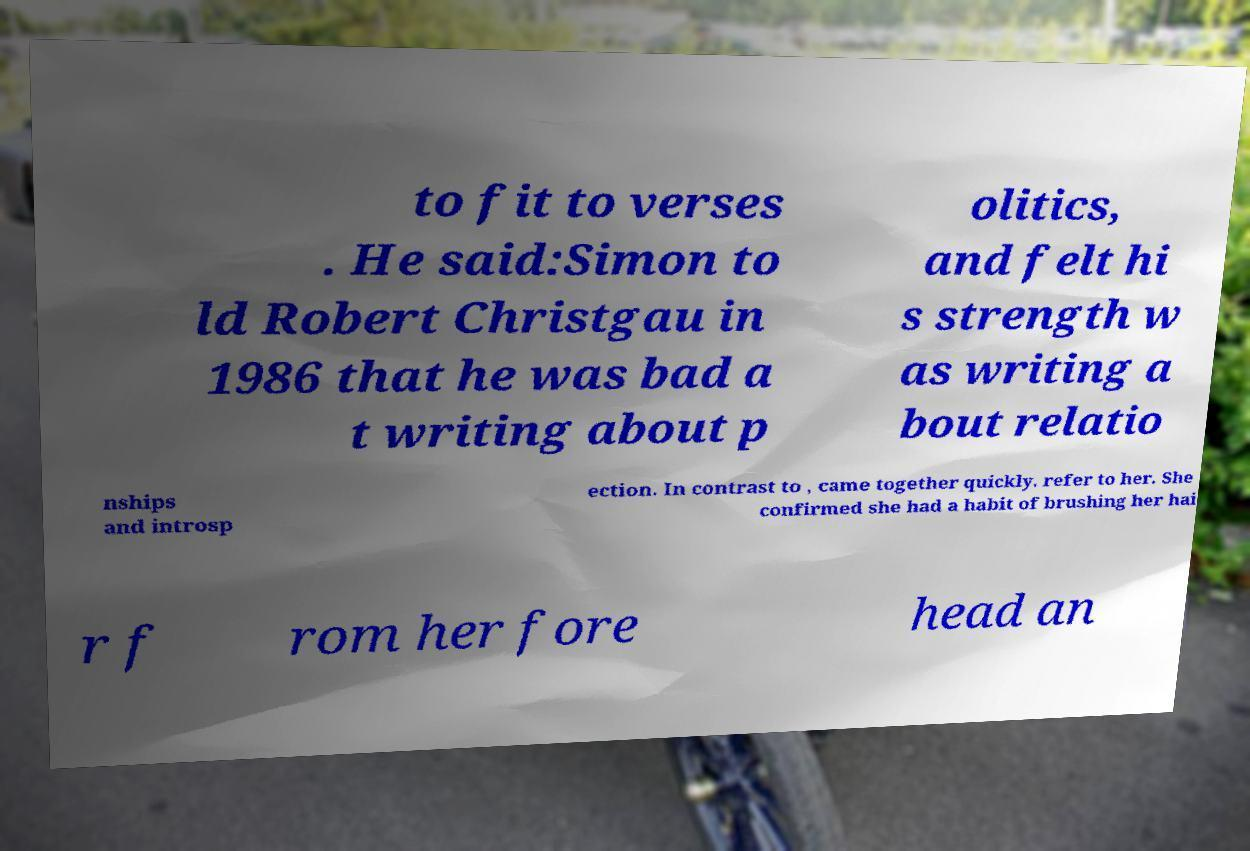I need the written content from this picture converted into text. Can you do that? to fit to verses . He said:Simon to ld Robert Christgau in 1986 that he was bad a t writing about p olitics, and felt hi s strength w as writing a bout relatio nships and introsp ection. In contrast to , came together quickly. refer to her. She confirmed she had a habit of brushing her hai r f rom her fore head an 